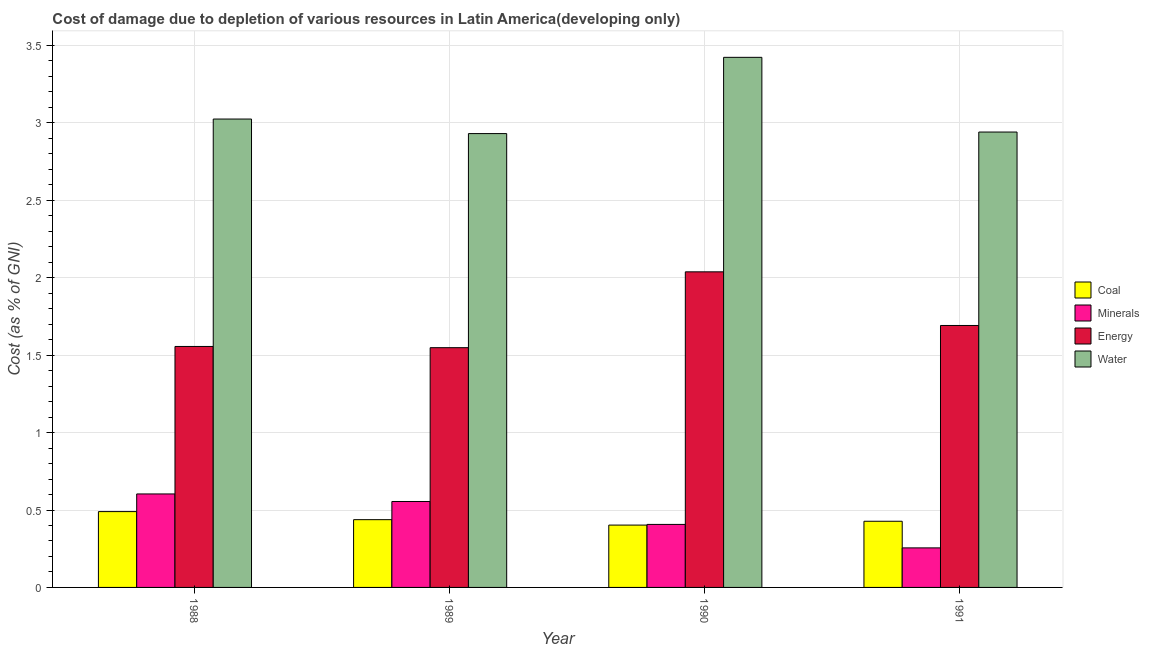How many different coloured bars are there?
Ensure brevity in your answer.  4. How many groups of bars are there?
Give a very brief answer. 4. Are the number of bars on each tick of the X-axis equal?
Ensure brevity in your answer.  Yes. How many bars are there on the 4th tick from the right?
Provide a short and direct response. 4. What is the label of the 1st group of bars from the left?
Your answer should be compact. 1988. In how many cases, is the number of bars for a given year not equal to the number of legend labels?
Provide a succinct answer. 0. What is the cost of damage due to depletion of water in 1990?
Provide a succinct answer. 3.42. Across all years, what is the maximum cost of damage due to depletion of energy?
Provide a succinct answer. 2.04. Across all years, what is the minimum cost of damage due to depletion of minerals?
Give a very brief answer. 0.26. What is the total cost of damage due to depletion of minerals in the graph?
Provide a succinct answer. 1.82. What is the difference between the cost of damage due to depletion of energy in 1989 and that in 1990?
Your answer should be very brief. -0.49. What is the difference between the cost of damage due to depletion of energy in 1988 and the cost of damage due to depletion of minerals in 1990?
Your answer should be very brief. -0.48. What is the average cost of damage due to depletion of coal per year?
Offer a very short reply. 0.44. In the year 1991, what is the difference between the cost of damage due to depletion of water and cost of damage due to depletion of energy?
Give a very brief answer. 0. What is the ratio of the cost of damage due to depletion of energy in 1989 to that in 1990?
Make the answer very short. 0.76. Is the cost of damage due to depletion of energy in 1988 less than that in 1989?
Your response must be concise. No. Is the difference between the cost of damage due to depletion of minerals in 1988 and 1989 greater than the difference between the cost of damage due to depletion of coal in 1988 and 1989?
Make the answer very short. No. What is the difference between the highest and the second highest cost of damage due to depletion of water?
Provide a short and direct response. 0.4. What is the difference between the highest and the lowest cost of damage due to depletion of energy?
Make the answer very short. 0.49. Is the sum of the cost of damage due to depletion of water in 1989 and 1990 greater than the maximum cost of damage due to depletion of coal across all years?
Offer a terse response. Yes. Is it the case that in every year, the sum of the cost of damage due to depletion of minerals and cost of damage due to depletion of energy is greater than the sum of cost of damage due to depletion of coal and cost of damage due to depletion of water?
Provide a succinct answer. No. What does the 1st bar from the left in 1990 represents?
Your answer should be very brief. Coal. What does the 1st bar from the right in 1990 represents?
Offer a very short reply. Water. How many bars are there?
Give a very brief answer. 16. Are all the bars in the graph horizontal?
Your answer should be compact. No. How many years are there in the graph?
Offer a very short reply. 4. What is the difference between two consecutive major ticks on the Y-axis?
Ensure brevity in your answer.  0.5. Does the graph contain grids?
Keep it short and to the point. Yes. How many legend labels are there?
Offer a very short reply. 4. What is the title of the graph?
Make the answer very short. Cost of damage due to depletion of various resources in Latin America(developing only) . What is the label or title of the Y-axis?
Provide a succinct answer. Cost (as % of GNI). What is the Cost (as % of GNI) in Coal in 1988?
Your answer should be compact. 0.49. What is the Cost (as % of GNI) of Minerals in 1988?
Keep it short and to the point. 0.6. What is the Cost (as % of GNI) in Energy in 1988?
Make the answer very short. 1.56. What is the Cost (as % of GNI) of Water in 1988?
Give a very brief answer. 3.02. What is the Cost (as % of GNI) of Coal in 1989?
Ensure brevity in your answer.  0.44. What is the Cost (as % of GNI) in Minerals in 1989?
Provide a short and direct response. 0.55. What is the Cost (as % of GNI) in Energy in 1989?
Offer a terse response. 1.55. What is the Cost (as % of GNI) in Water in 1989?
Offer a terse response. 2.93. What is the Cost (as % of GNI) in Coal in 1990?
Give a very brief answer. 0.4. What is the Cost (as % of GNI) in Minerals in 1990?
Keep it short and to the point. 0.41. What is the Cost (as % of GNI) of Energy in 1990?
Provide a succinct answer. 2.04. What is the Cost (as % of GNI) in Water in 1990?
Your answer should be very brief. 3.42. What is the Cost (as % of GNI) in Coal in 1991?
Offer a terse response. 0.43. What is the Cost (as % of GNI) in Minerals in 1991?
Offer a terse response. 0.26. What is the Cost (as % of GNI) of Energy in 1991?
Make the answer very short. 1.69. What is the Cost (as % of GNI) of Water in 1991?
Keep it short and to the point. 2.94. Across all years, what is the maximum Cost (as % of GNI) of Coal?
Make the answer very short. 0.49. Across all years, what is the maximum Cost (as % of GNI) of Minerals?
Keep it short and to the point. 0.6. Across all years, what is the maximum Cost (as % of GNI) in Energy?
Your answer should be very brief. 2.04. Across all years, what is the maximum Cost (as % of GNI) in Water?
Offer a very short reply. 3.42. Across all years, what is the minimum Cost (as % of GNI) in Coal?
Your answer should be compact. 0.4. Across all years, what is the minimum Cost (as % of GNI) of Minerals?
Provide a short and direct response. 0.26. Across all years, what is the minimum Cost (as % of GNI) of Energy?
Your answer should be compact. 1.55. Across all years, what is the minimum Cost (as % of GNI) in Water?
Make the answer very short. 2.93. What is the total Cost (as % of GNI) in Coal in the graph?
Your answer should be compact. 1.76. What is the total Cost (as % of GNI) of Minerals in the graph?
Ensure brevity in your answer.  1.82. What is the total Cost (as % of GNI) in Energy in the graph?
Make the answer very short. 6.83. What is the total Cost (as % of GNI) in Water in the graph?
Give a very brief answer. 12.32. What is the difference between the Cost (as % of GNI) of Coal in 1988 and that in 1989?
Offer a terse response. 0.05. What is the difference between the Cost (as % of GNI) in Minerals in 1988 and that in 1989?
Your answer should be very brief. 0.05. What is the difference between the Cost (as % of GNI) in Energy in 1988 and that in 1989?
Keep it short and to the point. 0.01. What is the difference between the Cost (as % of GNI) in Water in 1988 and that in 1989?
Keep it short and to the point. 0.09. What is the difference between the Cost (as % of GNI) in Coal in 1988 and that in 1990?
Your answer should be compact. 0.09. What is the difference between the Cost (as % of GNI) of Minerals in 1988 and that in 1990?
Offer a terse response. 0.2. What is the difference between the Cost (as % of GNI) in Energy in 1988 and that in 1990?
Your response must be concise. -0.48. What is the difference between the Cost (as % of GNI) of Water in 1988 and that in 1990?
Give a very brief answer. -0.4. What is the difference between the Cost (as % of GNI) of Coal in 1988 and that in 1991?
Offer a very short reply. 0.06. What is the difference between the Cost (as % of GNI) of Minerals in 1988 and that in 1991?
Give a very brief answer. 0.35. What is the difference between the Cost (as % of GNI) of Energy in 1988 and that in 1991?
Your answer should be compact. -0.14. What is the difference between the Cost (as % of GNI) of Water in 1988 and that in 1991?
Your answer should be compact. 0.08. What is the difference between the Cost (as % of GNI) in Coal in 1989 and that in 1990?
Your response must be concise. 0.04. What is the difference between the Cost (as % of GNI) of Minerals in 1989 and that in 1990?
Provide a short and direct response. 0.15. What is the difference between the Cost (as % of GNI) in Energy in 1989 and that in 1990?
Your answer should be very brief. -0.49. What is the difference between the Cost (as % of GNI) in Water in 1989 and that in 1990?
Your answer should be compact. -0.49. What is the difference between the Cost (as % of GNI) of Coal in 1989 and that in 1991?
Provide a short and direct response. 0.01. What is the difference between the Cost (as % of GNI) of Minerals in 1989 and that in 1991?
Provide a succinct answer. 0.3. What is the difference between the Cost (as % of GNI) of Energy in 1989 and that in 1991?
Provide a short and direct response. -0.14. What is the difference between the Cost (as % of GNI) of Water in 1989 and that in 1991?
Provide a succinct answer. -0.01. What is the difference between the Cost (as % of GNI) of Coal in 1990 and that in 1991?
Your answer should be very brief. -0.02. What is the difference between the Cost (as % of GNI) of Minerals in 1990 and that in 1991?
Make the answer very short. 0.15. What is the difference between the Cost (as % of GNI) in Energy in 1990 and that in 1991?
Your response must be concise. 0.35. What is the difference between the Cost (as % of GNI) of Water in 1990 and that in 1991?
Your answer should be very brief. 0.48. What is the difference between the Cost (as % of GNI) of Coal in 1988 and the Cost (as % of GNI) of Minerals in 1989?
Provide a short and direct response. -0.07. What is the difference between the Cost (as % of GNI) in Coal in 1988 and the Cost (as % of GNI) in Energy in 1989?
Your answer should be very brief. -1.06. What is the difference between the Cost (as % of GNI) of Coal in 1988 and the Cost (as % of GNI) of Water in 1989?
Your answer should be compact. -2.44. What is the difference between the Cost (as % of GNI) of Minerals in 1988 and the Cost (as % of GNI) of Energy in 1989?
Ensure brevity in your answer.  -0.94. What is the difference between the Cost (as % of GNI) in Minerals in 1988 and the Cost (as % of GNI) in Water in 1989?
Offer a very short reply. -2.33. What is the difference between the Cost (as % of GNI) of Energy in 1988 and the Cost (as % of GNI) of Water in 1989?
Make the answer very short. -1.37. What is the difference between the Cost (as % of GNI) of Coal in 1988 and the Cost (as % of GNI) of Minerals in 1990?
Make the answer very short. 0.08. What is the difference between the Cost (as % of GNI) of Coal in 1988 and the Cost (as % of GNI) of Energy in 1990?
Ensure brevity in your answer.  -1.55. What is the difference between the Cost (as % of GNI) in Coal in 1988 and the Cost (as % of GNI) in Water in 1990?
Provide a short and direct response. -2.93. What is the difference between the Cost (as % of GNI) of Minerals in 1988 and the Cost (as % of GNI) of Energy in 1990?
Keep it short and to the point. -1.43. What is the difference between the Cost (as % of GNI) of Minerals in 1988 and the Cost (as % of GNI) of Water in 1990?
Your answer should be very brief. -2.82. What is the difference between the Cost (as % of GNI) in Energy in 1988 and the Cost (as % of GNI) in Water in 1990?
Provide a short and direct response. -1.87. What is the difference between the Cost (as % of GNI) in Coal in 1988 and the Cost (as % of GNI) in Minerals in 1991?
Offer a terse response. 0.23. What is the difference between the Cost (as % of GNI) of Coal in 1988 and the Cost (as % of GNI) of Energy in 1991?
Give a very brief answer. -1.2. What is the difference between the Cost (as % of GNI) in Coal in 1988 and the Cost (as % of GNI) in Water in 1991?
Offer a terse response. -2.45. What is the difference between the Cost (as % of GNI) of Minerals in 1988 and the Cost (as % of GNI) of Energy in 1991?
Keep it short and to the point. -1.09. What is the difference between the Cost (as % of GNI) of Minerals in 1988 and the Cost (as % of GNI) of Water in 1991?
Your response must be concise. -2.34. What is the difference between the Cost (as % of GNI) of Energy in 1988 and the Cost (as % of GNI) of Water in 1991?
Keep it short and to the point. -1.38. What is the difference between the Cost (as % of GNI) in Coal in 1989 and the Cost (as % of GNI) in Minerals in 1990?
Keep it short and to the point. 0.03. What is the difference between the Cost (as % of GNI) in Coal in 1989 and the Cost (as % of GNI) in Energy in 1990?
Make the answer very short. -1.6. What is the difference between the Cost (as % of GNI) of Coal in 1989 and the Cost (as % of GNI) of Water in 1990?
Keep it short and to the point. -2.99. What is the difference between the Cost (as % of GNI) in Minerals in 1989 and the Cost (as % of GNI) in Energy in 1990?
Offer a terse response. -1.48. What is the difference between the Cost (as % of GNI) of Minerals in 1989 and the Cost (as % of GNI) of Water in 1990?
Make the answer very short. -2.87. What is the difference between the Cost (as % of GNI) in Energy in 1989 and the Cost (as % of GNI) in Water in 1990?
Provide a short and direct response. -1.88. What is the difference between the Cost (as % of GNI) in Coal in 1989 and the Cost (as % of GNI) in Minerals in 1991?
Offer a terse response. 0.18. What is the difference between the Cost (as % of GNI) of Coal in 1989 and the Cost (as % of GNI) of Energy in 1991?
Offer a very short reply. -1.25. What is the difference between the Cost (as % of GNI) in Coal in 1989 and the Cost (as % of GNI) in Water in 1991?
Provide a succinct answer. -2.5. What is the difference between the Cost (as % of GNI) of Minerals in 1989 and the Cost (as % of GNI) of Energy in 1991?
Keep it short and to the point. -1.14. What is the difference between the Cost (as % of GNI) in Minerals in 1989 and the Cost (as % of GNI) in Water in 1991?
Provide a short and direct response. -2.39. What is the difference between the Cost (as % of GNI) in Energy in 1989 and the Cost (as % of GNI) in Water in 1991?
Offer a very short reply. -1.39. What is the difference between the Cost (as % of GNI) in Coal in 1990 and the Cost (as % of GNI) in Minerals in 1991?
Ensure brevity in your answer.  0.15. What is the difference between the Cost (as % of GNI) in Coal in 1990 and the Cost (as % of GNI) in Energy in 1991?
Keep it short and to the point. -1.29. What is the difference between the Cost (as % of GNI) of Coal in 1990 and the Cost (as % of GNI) of Water in 1991?
Keep it short and to the point. -2.54. What is the difference between the Cost (as % of GNI) in Minerals in 1990 and the Cost (as % of GNI) in Energy in 1991?
Provide a succinct answer. -1.28. What is the difference between the Cost (as % of GNI) in Minerals in 1990 and the Cost (as % of GNI) in Water in 1991?
Make the answer very short. -2.53. What is the difference between the Cost (as % of GNI) of Energy in 1990 and the Cost (as % of GNI) of Water in 1991?
Make the answer very short. -0.9. What is the average Cost (as % of GNI) of Coal per year?
Offer a very short reply. 0.44. What is the average Cost (as % of GNI) of Minerals per year?
Ensure brevity in your answer.  0.46. What is the average Cost (as % of GNI) in Energy per year?
Ensure brevity in your answer.  1.71. What is the average Cost (as % of GNI) in Water per year?
Ensure brevity in your answer.  3.08. In the year 1988, what is the difference between the Cost (as % of GNI) in Coal and Cost (as % of GNI) in Minerals?
Your answer should be compact. -0.11. In the year 1988, what is the difference between the Cost (as % of GNI) of Coal and Cost (as % of GNI) of Energy?
Your answer should be compact. -1.07. In the year 1988, what is the difference between the Cost (as % of GNI) in Coal and Cost (as % of GNI) in Water?
Provide a short and direct response. -2.54. In the year 1988, what is the difference between the Cost (as % of GNI) of Minerals and Cost (as % of GNI) of Energy?
Your answer should be very brief. -0.95. In the year 1988, what is the difference between the Cost (as % of GNI) in Minerals and Cost (as % of GNI) in Water?
Offer a terse response. -2.42. In the year 1988, what is the difference between the Cost (as % of GNI) in Energy and Cost (as % of GNI) in Water?
Keep it short and to the point. -1.47. In the year 1989, what is the difference between the Cost (as % of GNI) in Coal and Cost (as % of GNI) in Minerals?
Keep it short and to the point. -0.12. In the year 1989, what is the difference between the Cost (as % of GNI) of Coal and Cost (as % of GNI) of Energy?
Make the answer very short. -1.11. In the year 1989, what is the difference between the Cost (as % of GNI) of Coal and Cost (as % of GNI) of Water?
Offer a very short reply. -2.49. In the year 1989, what is the difference between the Cost (as % of GNI) in Minerals and Cost (as % of GNI) in Energy?
Keep it short and to the point. -0.99. In the year 1989, what is the difference between the Cost (as % of GNI) in Minerals and Cost (as % of GNI) in Water?
Your answer should be compact. -2.38. In the year 1989, what is the difference between the Cost (as % of GNI) in Energy and Cost (as % of GNI) in Water?
Your response must be concise. -1.38. In the year 1990, what is the difference between the Cost (as % of GNI) of Coal and Cost (as % of GNI) of Minerals?
Keep it short and to the point. -0. In the year 1990, what is the difference between the Cost (as % of GNI) in Coal and Cost (as % of GNI) in Energy?
Make the answer very short. -1.64. In the year 1990, what is the difference between the Cost (as % of GNI) of Coal and Cost (as % of GNI) of Water?
Your answer should be compact. -3.02. In the year 1990, what is the difference between the Cost (as % of GNI) in Minerals and Cost (as % of GNI) in Energy?
Keep it short and to the point. -1.63. In the year 1990, what is the difference between the Cost (as % of GNI) of Minerals and Cost (as % of GNI) of Water?
Your response must be concise. -3.02. In the year 1990, what is the difference between the Cost (as % of GNI) of Energy and Cost (as % of GNI) of Water?
Give a very brief answer. -1.39. In the year 1991, what is the difference between the Cost (as % of GNI) in Coal and Cost (as % of GNI) in Minerals?
Provide a short and direct response. 0.17. In the year 1991, what is the difference between the Cost (as % of GNI) of Coal and Cost (as % of GNI) of Energy?
Make the answer very short. -1.26. In the year 1991, what is the difference between the Cost (as % of GNI) in Coal and Cost (as % of GNI) in Water?
Ensure brevity in your answer.  -2.51. In the year 1991, what is the difference between the Cost (as % of GNI) in Minerals and Cost (as % of GNI) in Energy?
Your answer should be very brief. -1.44. In the year 1991, what is the difference between the Cost (as % of GNI) in Minerals and Cost (as % of GNI) in Water?
Provide a short and direct response. -2.69. In the year 1991, what is the difference between the Cost (as % of GNI) of Energy and Cost (as % of GNI) of Water?
Make the answer very short. -1.25. What is the ratio of the Cost (as % of GNI) in Coal in 1988 to that in 1989?
Keep it short and to the point. 1.12. What is the ratio of the Cost (as % of GNI) in Minerals in 1988 to that in 1989?
Your answer should be compact. 1.09. What is the ratio of the Cost (as % of GNI) in Energy in 1988 to that in 1989?
Keep it short and to the point. 1.01. What is the ratio of the Cost (as % of GNI) of Water in 1988 to that in 1989?
Ensure brevity in your answer.  1.03. What is the ratio of the Cost (as % of GNI) of Coal in 1988 to that in 1990?
Ensure brevity in your answer.  1.22. What is the ratio of the Cost (as % of GNI) of Minerals in 1988 to that in 1990?
Make the answer very short. 1.48. What is the ratio of the Cost (as % of GNI) of Energy in 1988 to that in 1990?
Make the answer very short. 0.76. What is the ratio of the Cost (as % of GNI) in Water in 1988 to that in 1990?
Provide a short and direct response. 0.88. What is the ratio of the Cost (as % of GNI) of Coal in 1988 to that in 1991?
Give a very brief answer. 1.15. What is the ratio of the Cost (as % of GNI) in Minerals in 1988 to that in 1991?
Your answer should be compact. 2.36. What is the ratio of the Cost (as % of GNI) of Energy in 1988 to that in 1991?
Keep it short and to the point. 0.92. What is the ratio of the Cost (as % of GNI) of Water in 1988 to that in 1991?
Your answer should be compact. 1.03. What is the ratio of the Cost (as % of GNI) of Coal in 1989 to that in 1990?
Offer a terse response. 1.09. What is the ratio of the Cost (as % of GNI) of Minerals in 1989 to that in 1990?
Your answer should be very brief. 1.36. What is the ratio of the Cost (as % of GNI) in Energy in 1989 to that in 1990?
Offer a very short reply. 0.76. What is the ratio of the Cost (as % of GNI) of Water in 1989 to that in 1990?
Offer a very short reply. 0.86. What is the ratio of the Cost (as % of GNI) of Minerals in 1989 to that in 1991?
Offer a terse response. 2.17. What is the ratio of the Cost (as % of GNI) of Energy in 1989 to that in 1991?
Give a very brief answer. 0.92. What is the ratio of the Cost (as % of GNI) in Coal in 1990 to that in 1991?
Your answer should be compact. 0.94. What is the ratio of the Cost (as % of GNI) of Minerals in 1990 to that in 1991?
Offer a terse response. 1.59. What is the ratio of the Cost (as % of GNI) in Energy in 1990 to that in 1991?
Offer a very short reply. 1.2. What is the ratio of the Cost (as % of GNI) of Water in 1990 to that in 1991?
Give a very brief answer. 1.16. What is the difference between the highest and the second highest Cost (as % of GNI) of Coal?
Offer a very short reply. 0.05. What is the difference between the highest and the second highest Cost (as % of GNI) of Minerals?
Offer a very short reply. 0.05. What is the difference between the highest and the second highest Cost (as % of GNI) of Energy?
Your answer should be compact. 0.35. What is the difference between the highest and the second highest Cost (as % of GNI) of Water?
Offer a terse response. 0.4. What is the difference between the highest and the lowest Cost (as % of GNI) of Coal?
Provide a short and direct response. 0.09. What is the difference between the highest and the lowest Cost (as % of GNI) in Minerals?
Provide a succinct answer. 0.35. What is the difference between the highest and the lowest Cost (as % of GNI) in Energy?
Your answer should be compact. 0.49. What is the difference between the highest and the lowest Cost (as % of GNI) of Water?
Provide a succinct answer. 0.49. 